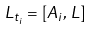Convert formula to latex. <formula><loc_0><loc_0><loc_500><loc_500>L _ { t _ { i } } = [ A _ { i } , \, L ]</formula> 